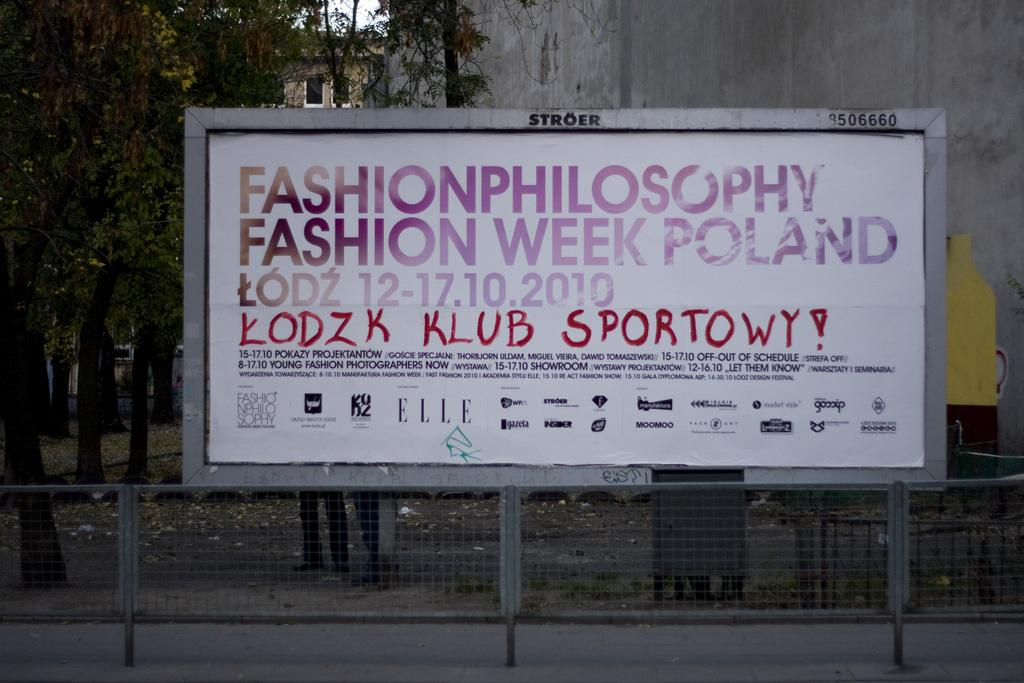Provide a one-sentence caption for the provided image. Fashion week is being advertised on a billboard in Poland. 